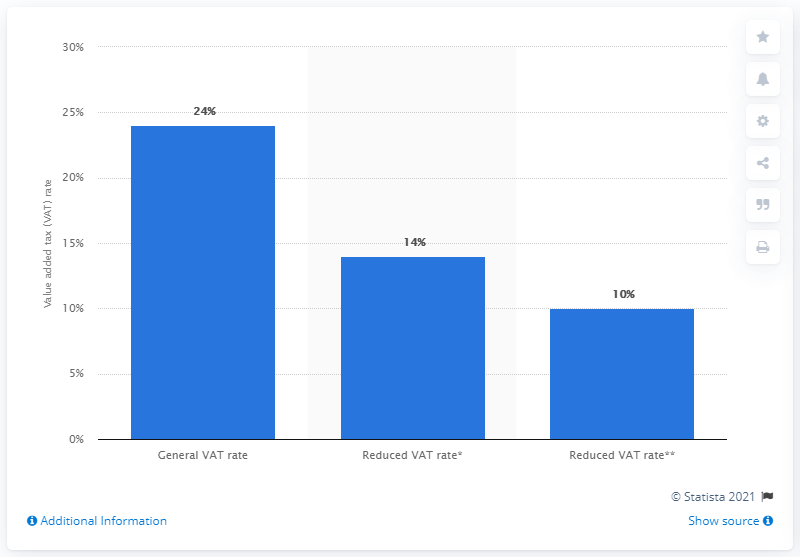Specify some key components in this picture. The standard VAT rate on most goods and services was 24%. The reduced tax rate for groceries, fodder, restaurant and catering services was 14%. 